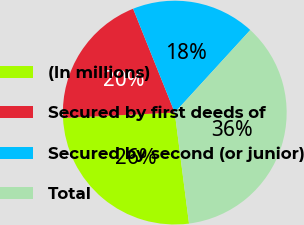Convert chart. <chart><loc_0><loc_0><loc_500><loc_500><pie_chart><fcel>(In millions)<fcel>Secured by first deeds of<fcel>Secured by second (or junior)<fcel>Total<nl><fcel>26.27%<fcel>19.69%<fcel>17.86%<fcel>36.17%<nl></chart> 